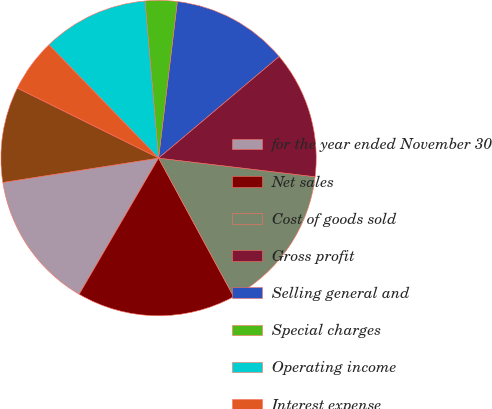<chart> <loc_0><loc_0><loc_500><loc_500><pie_chart><fcel>for the year ended November 30<fcel>Net sales<fcel>Cost of goods sold<fcel>Gross profit<fcel>Selling general and<fcel>Special charges<fcel>Operating income<fcel>Interest expense<fcel>Other income net<fcel>Income from consolidated<nl><fcel>14.13%<fcel>16.3%<fcel>15.21%<fcel>13.04%<fcel>11.95%<fcel>3.27%<fcel>10.87%<fcel>5.44%<fcel>0.01%<fcel>9.78%<nl></chart> 